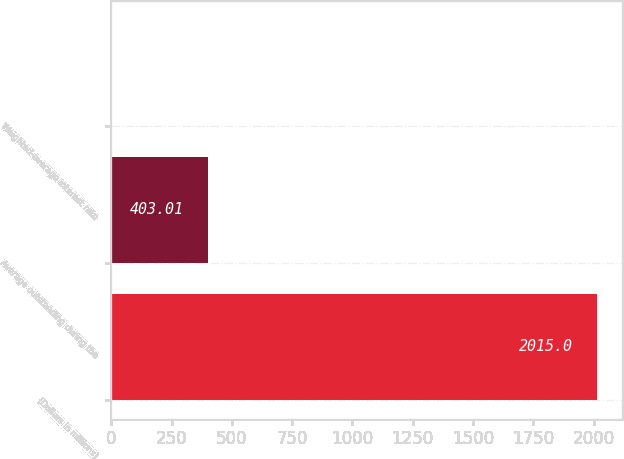Convert chart. <chart><loc_0><loc_0><loc_500><loc_500><bar_chart><fcel>(Dollars in millions)<fcel>Average outstanding during the<fcel>Weighted-average interest rate<nl><fcel>2015<fcel>403.01<fcel>0.01<nl></chart> 